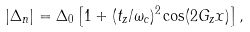Convert formula to latex. <formula><loc_0><loc_0><loc_500><loc_500>| \Delta _ { n } | = \Delta _ { 0 } \left [ 1 + ( t _ { z } / { \omega _ { c } } ) ^ { 2 } \cos ( 2 G _ { z } x ) \right ] ,</formula> 